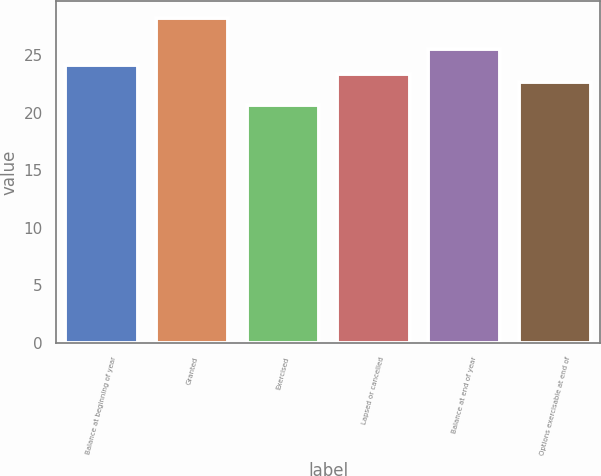Convert chart to OTSL. <chart><loc_0><loc_0><loc_500><loc_500><bar_chart><fcel>Balance at beginning of year<fcel>Granted<fcel>Exercised<fcel>Lapsed or cancelled<fcel>Balance at end of year<fcel>Options exercisable at end of<nl><fcel>24.14<fcel>28.25<fcel>20.64<fcel>23.38<fcel>25.49<fcel>22.62<nl></chart> 